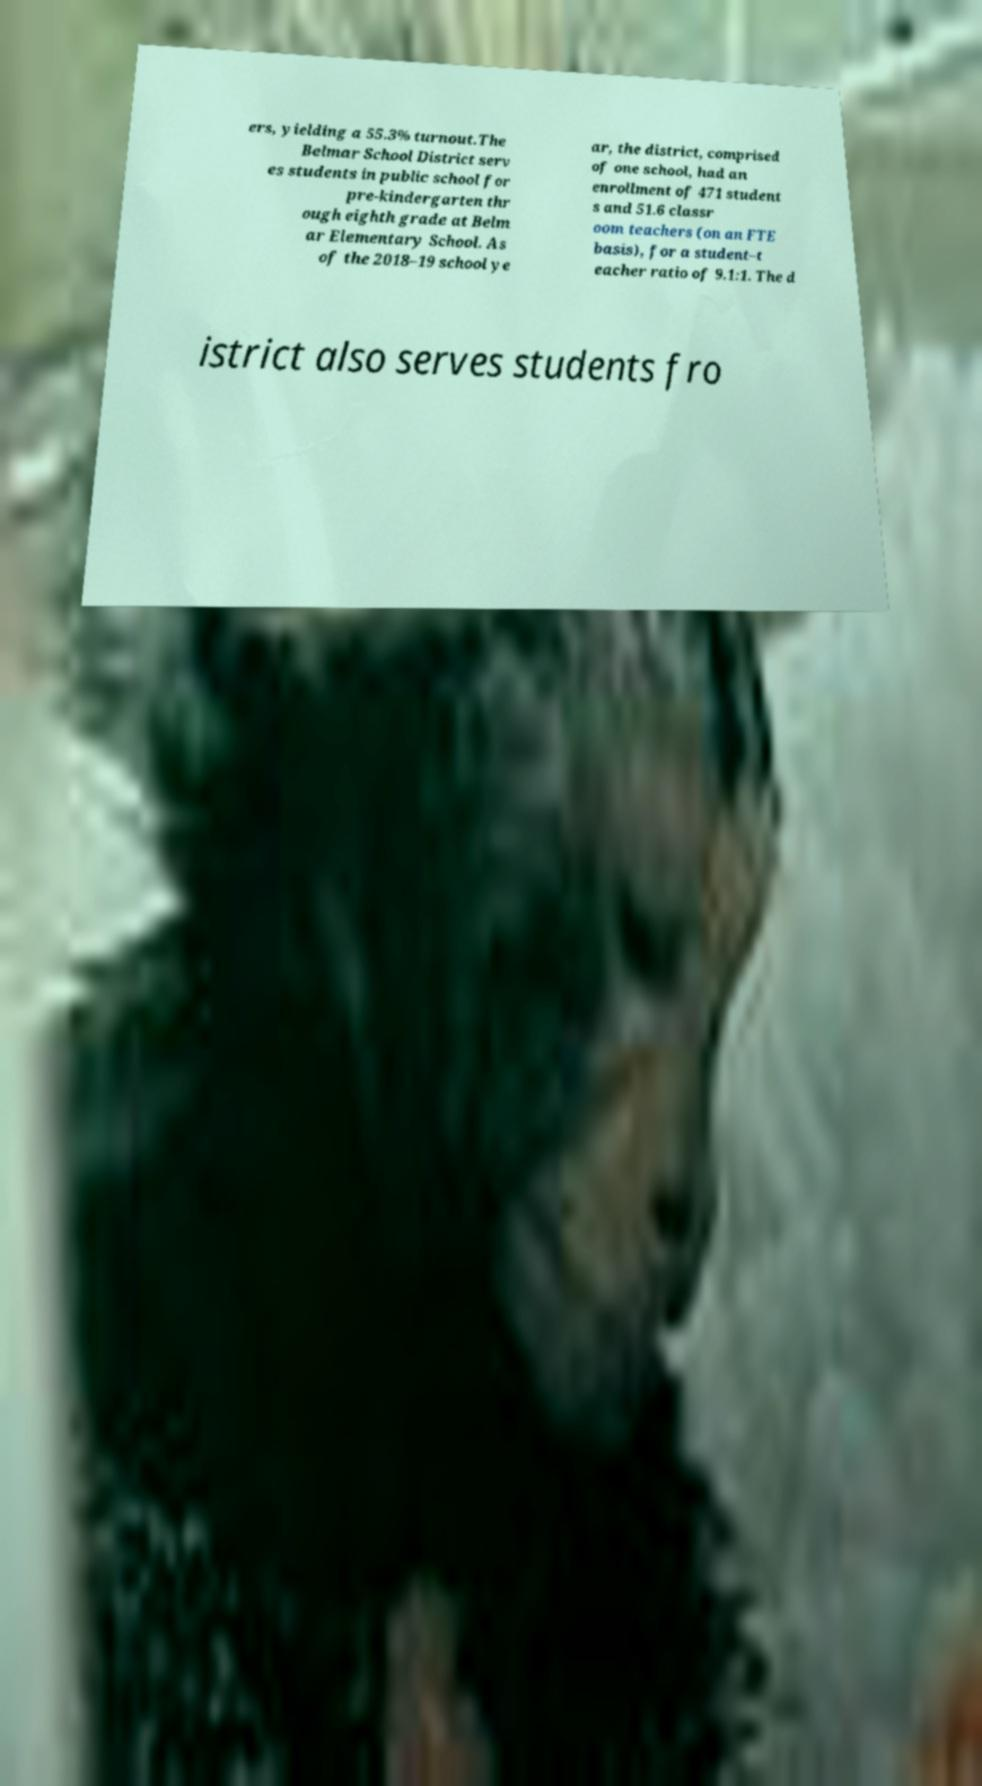Please identify and transcribe the text found in this image. ers, yielding a 55.3% turnout.The Belmar School District serv es students in public school for pre-kindergarten thr ough eighth grade at Belm ar Elementary School. As of the 2018–19 school ye ar, the district, comprised of one school, had an enrollment of 471 student s and 51.6 classr oom teachers (on an FTE basis), for a student–t eacher ratio of 9.1:1. The d istrict also serves students fro 